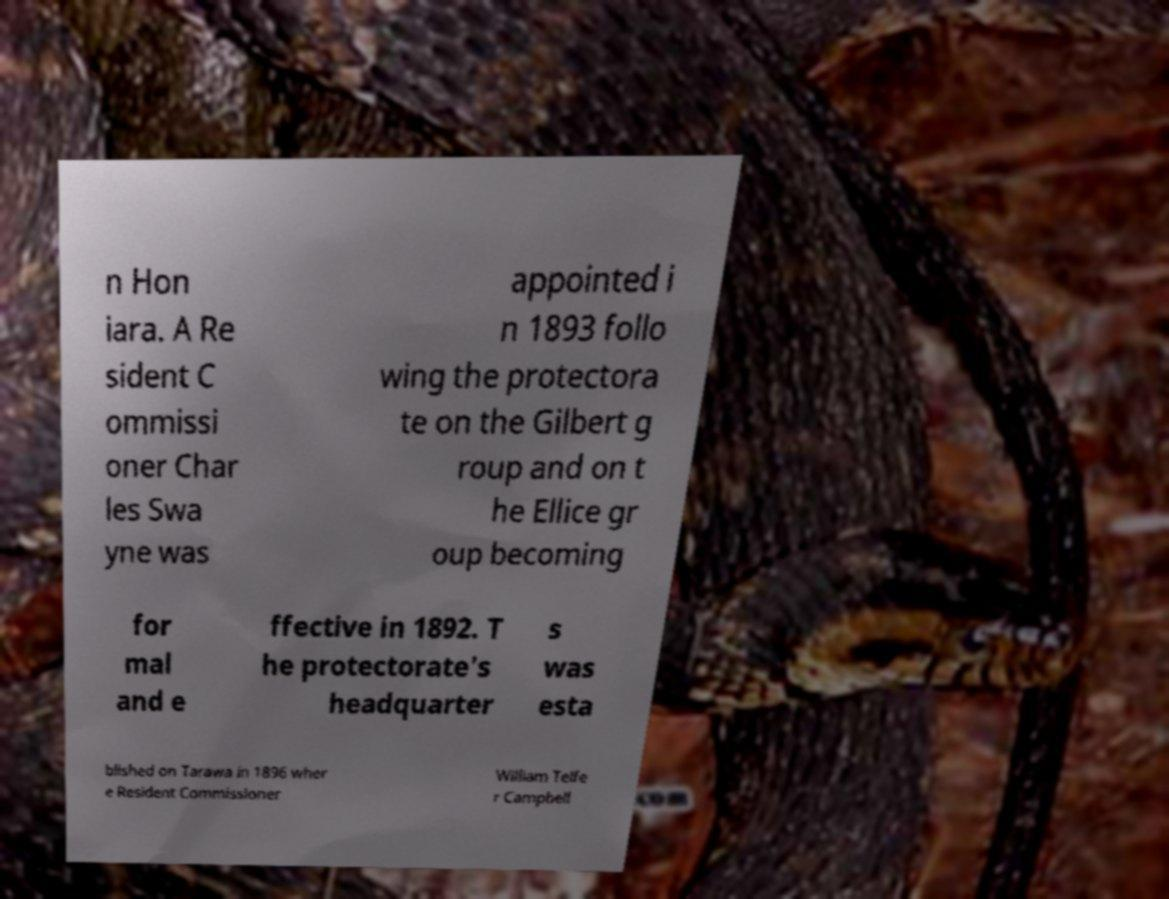There's text embedded in this image that I need extracted. Can you transcribe it verbatim? n Hon iara. A Re sident C ommissi oner Char les Swa yne was appointed i n 1893 follo wing the protectora te on the Gilbert g roup and on t he Ellice gr oup becoming for mal and e ffective in 1892. T he protectorate's headquarter s was esta blished on Tarawa in 1896 wher e Resident Commissioner William Telfe r Campbell 